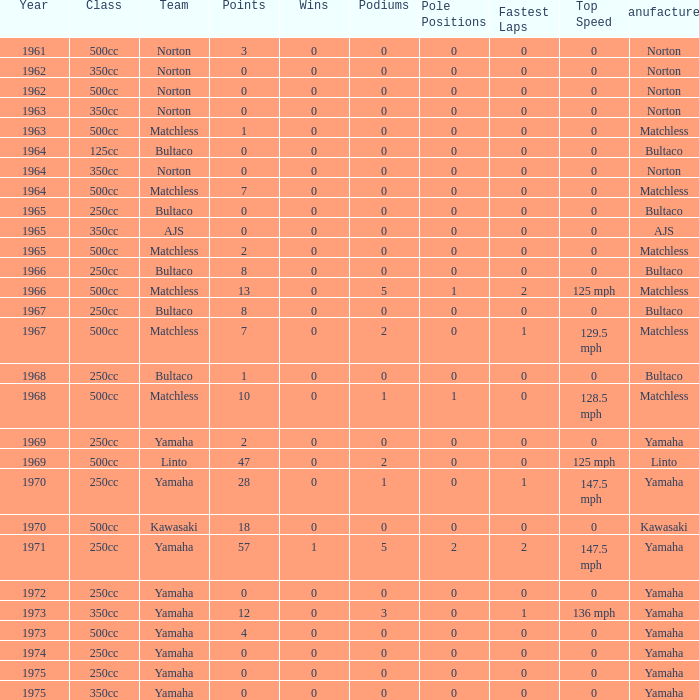Which class corresponds to more than 2 points, wins greater than 0, and a year earlier than 1973? 250cc. 